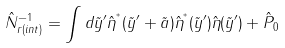Convert formula to latex. <formula><loc_0><loc_0><loc_500><loc_500>\hat { N } _ { r ( i n t ) } ^ { - 1 } = \int d \tilde { y } ^ { \prime } \hat { \eta } ^ { ^ { * } } ( \tilde { y } ^ { \prime } + \tilde { a } ) \hat { \eta } ^ { ^ { * } } ( \tilde { y } ^ { \prime } ) \hat { \eta } ( \tilde { y } ^ { \prime } ) + \hat { P } _ { 0 }</formula> 